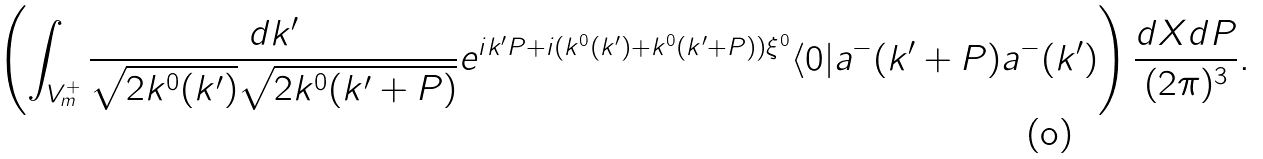<formula> <loc_0><loc_0><loc_500><loc_500>\left ( \int _ { V ^ { + } _ { m } } \frac { d { k } ^ { \prime } } { \sqrt { 2 k ^ { 0 } ( { k ^ { \prime } } ) } \sqrt { 2 k ^ { 0 } ( { k ^ { \prime } + P } ) } } e ^ { i { k ^ { \prime } P } + i ( k ^ { 0 } ( { k ^ { \prime } } ) + k ^ { 0 } ( { k ^ { \prime } + P } ) ) \xi ^ { 0 } } \langle 0 | a ^ { - } ( { k ^ { \prime } + P ) a ^ { - } ( { k ^ { \prime } } } ) \right ) \frac { d { X } d { P } } { ( 2 \pi ) ^ { 3 } } .</formula> 